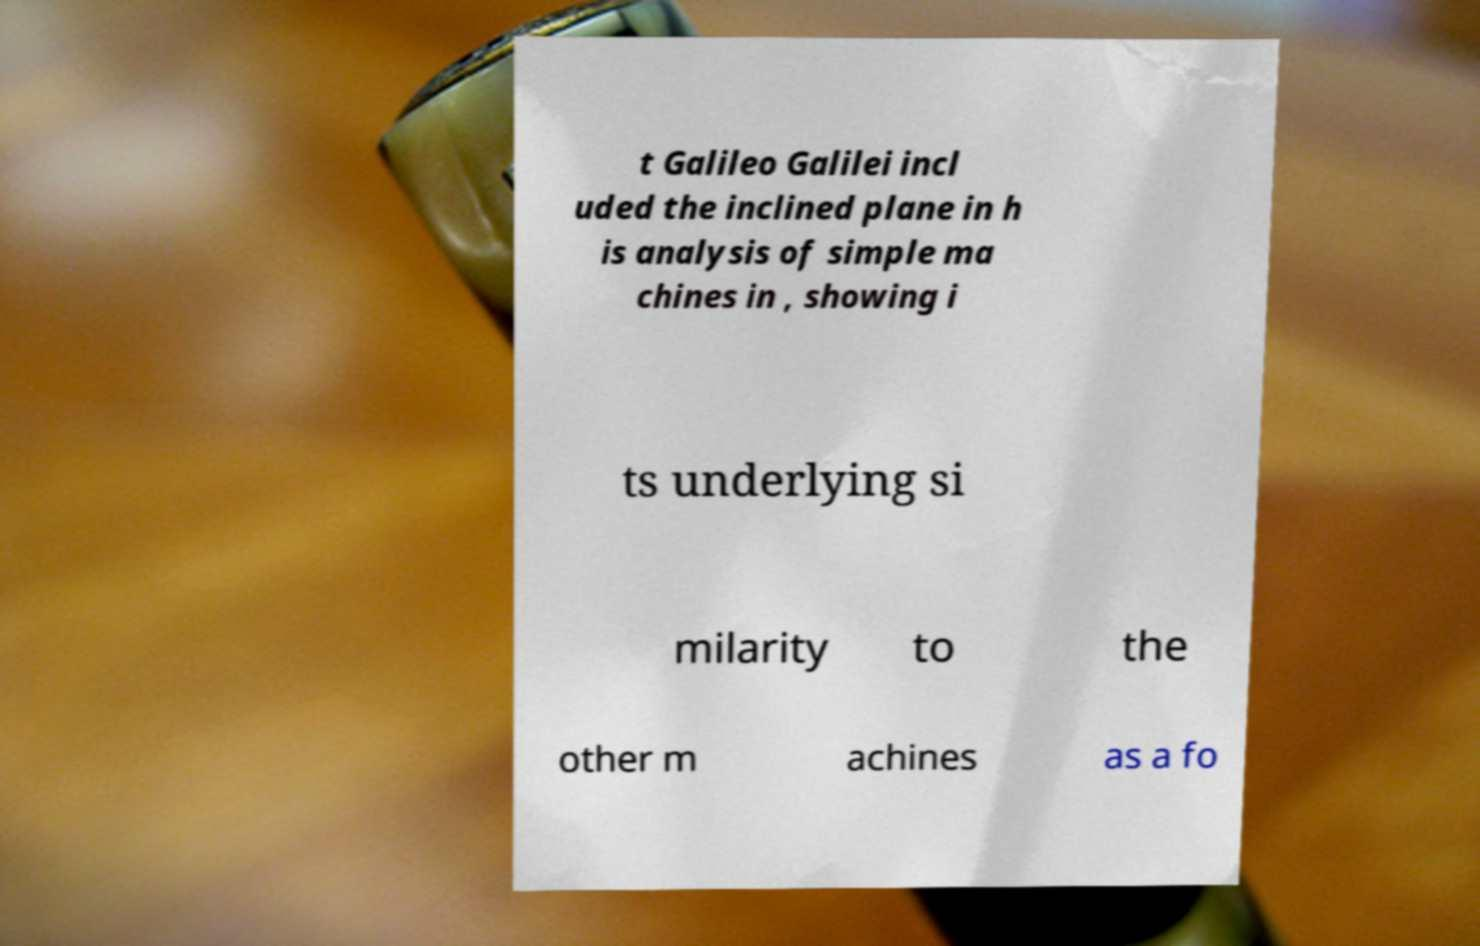Please read and relay the text visible in this image. What does it say? t Galileo Galilei incl uded the inclined plane in h is analysis of simple ma chines in , showing i ts underlying si milarity to the other m achines as a fo 